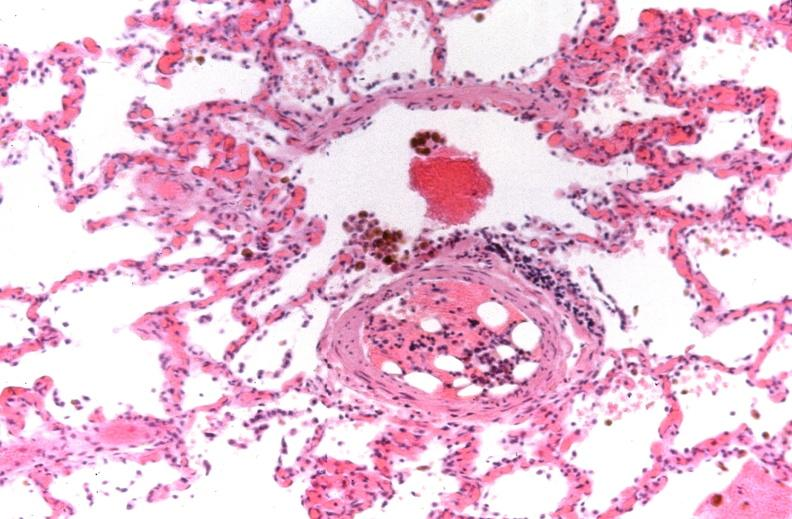what is present?
Answer the question using a single word or phrase. Respiratory 